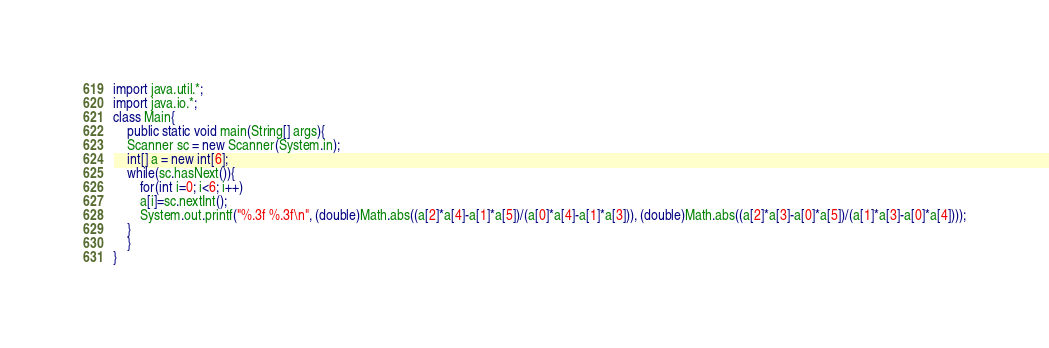<code> <loc_0><loc_0><loc_500><loc_500><_Java_>import java.util.*;
import java.io.*;
class Main{
    public static void main(String[] args){
	Scanner sc = new Scanner(System.in);
	int[] a = new int[6];
	while(sc.hasNext()){
	    for(int i=0; i<6; i++)
		a[i]=sc.nextInt();
	    System.out.printf("%.3f %.3f\n", (double)Math.abs((a[2]*a[4]-a[1]*a[5])/(a[0]*a[4]-a[1]*a[3])), (double)Math.abs((a[2]*a[3]-a[0]*a[5])/(a[1]*a[3]-a[0]*a[4])));
	}
    }
}</code> 